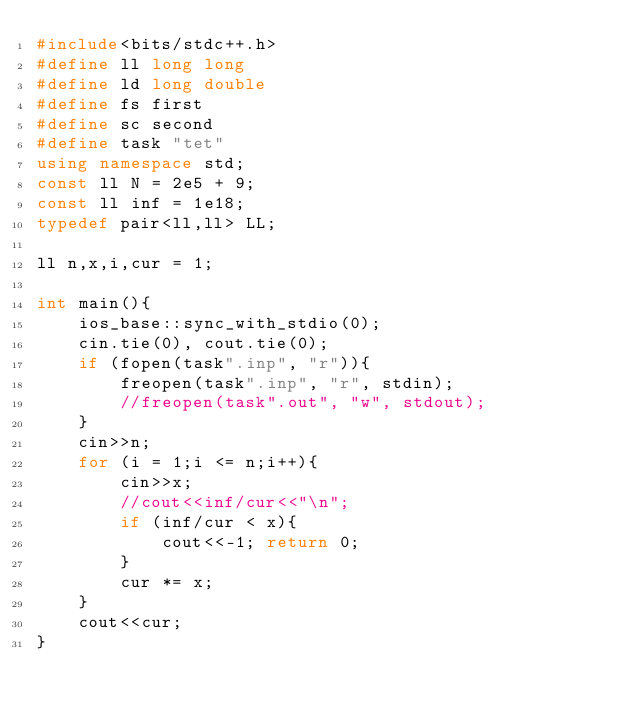<code> <loc_0><loc_0><loc_500><loc_500><_C++_>#include<bits/stdc++.h>
#define ll long long
#define ld long double
#define fs first
#define sc second
#define task "tet"
using namespace std;
const ll N = 2e5 + 9;
const ll inf = 1e18;
typedef pair<ll,ll> LL;

ll n,x,i,cur = 1;

int main(){
    ios_base::sync_with_stdio(0);
    cin.tie(0), cout.tie(0);
    if (fopen(task".inp", "r")){
        freopen(task".inp", "r", stdin);
        //freopen(task".out", "w", stdout);
    }
    cin>>n;
    for (i = 1;i <= n;i++){
        cin>>x;
        //cout<<inf/cur<<"\n";
        if (inf/cur < x){
            cout<<-1; return 0;
        }
        cur *= x;
    }
    cout<<cur;
}
</code> 